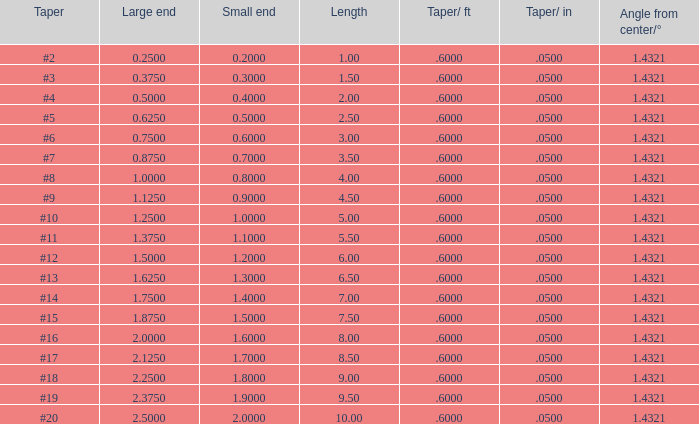Which Taper/ft that has a Large end smaller than 0.5, and a Taper of #2? 0.6. 